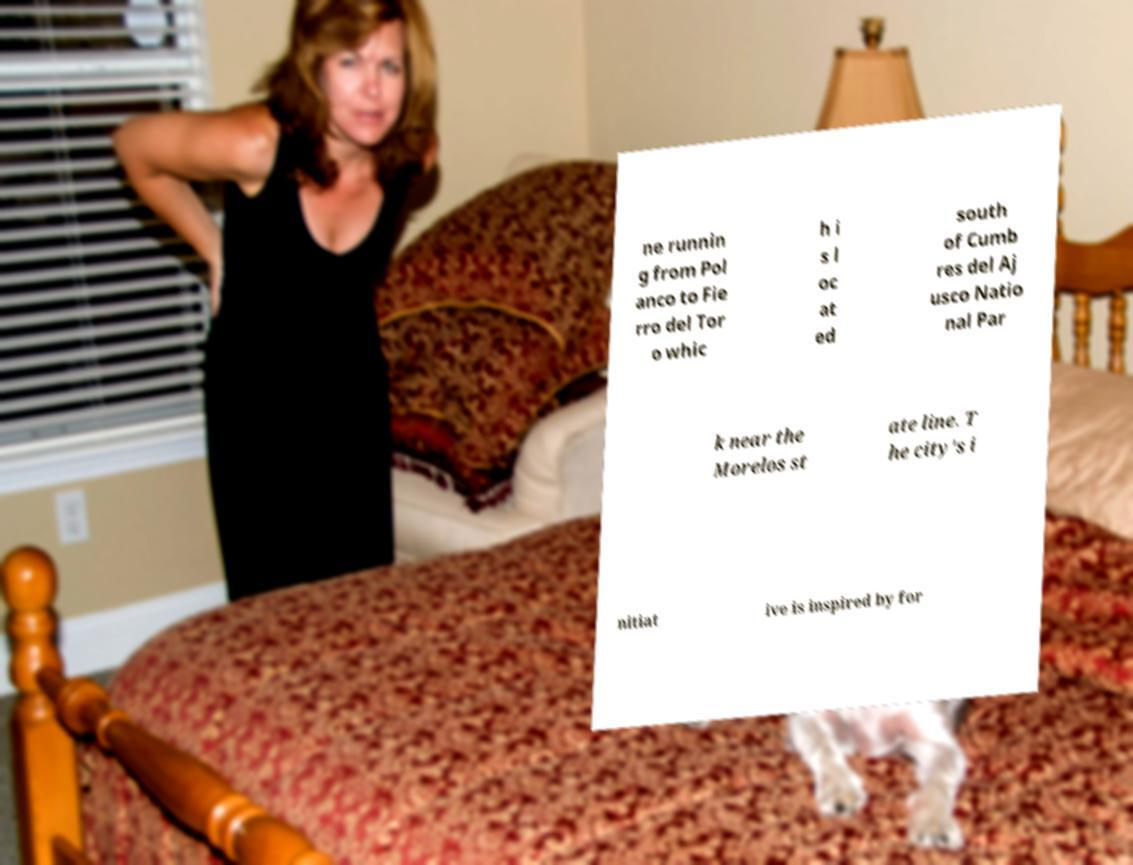Can you accurately transcribe the text from the provided image for me? ne runnin g from Pol anco to Fie rro del Tor o whic h i s l oc at ed south of Cumb res del Aj usco Natio nal Par k near the Morelos st ate line. T he city's i nitiat ive is inspired by for 